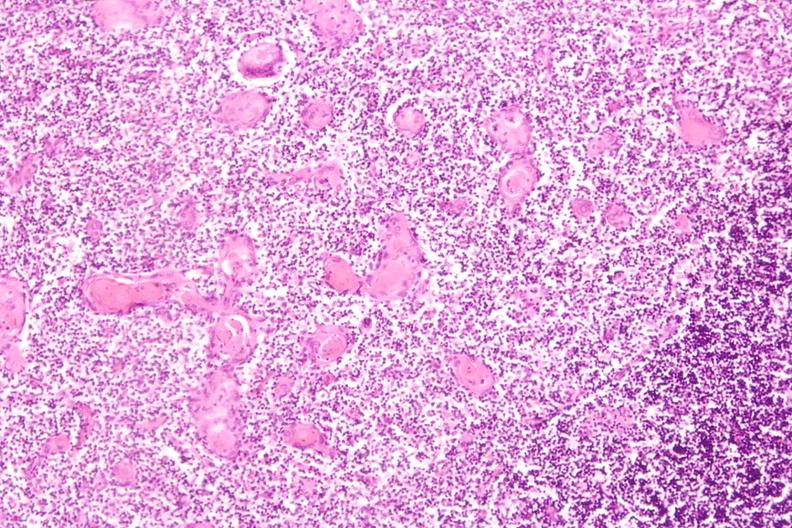what does this image show?
Answer the question using a single word or phrase. Thymus 